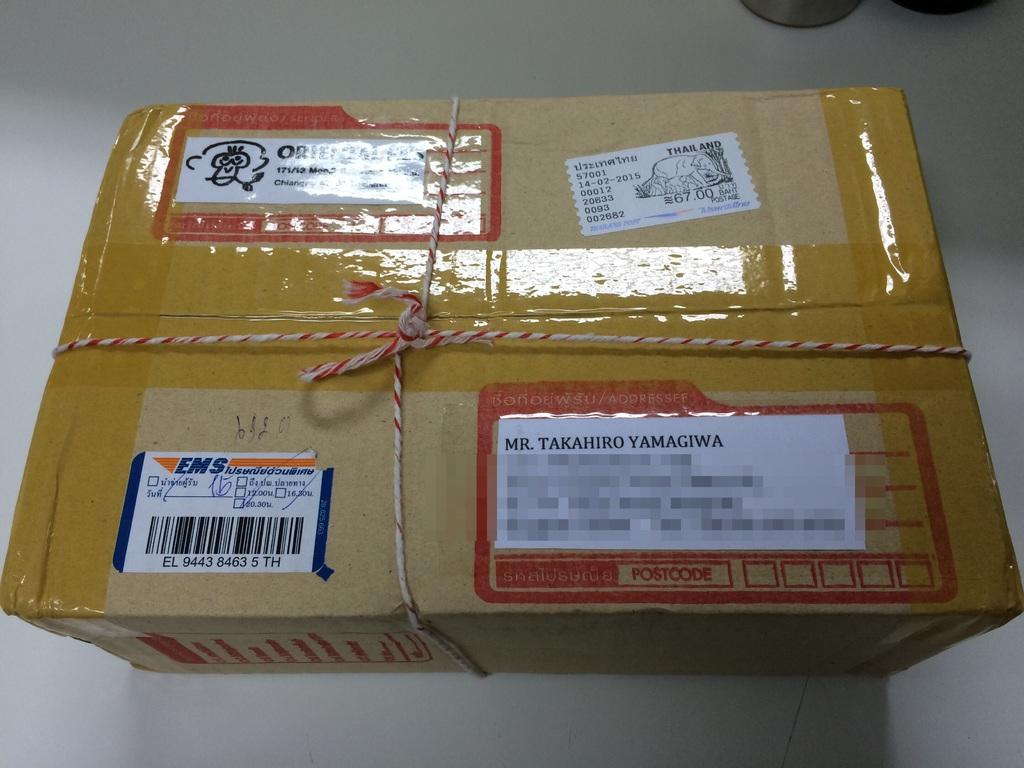<image>
Render a clear and concise summary of the photo. A package with a label by EMS in the left corner. 